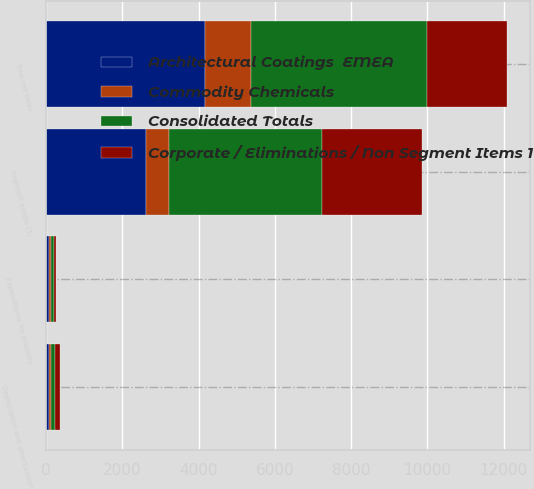Convert chart. <chart><loc_0><loc_0><loc_500><loc_500><stacked_bar_chart><ecel><fcel>Total net sales<fcel>Depreciation and amortization<fcel>Segment assets (5)<fcel>Expenditures for property<nl><fcel>Consolidated Totals<fcel>4626<fcel>115<fcel>4017<fcel>79<nl><fcel>Architectural Coatings  EMEA<fcel>4158<fcel>90<fcel>2614<fcel>73<nl><fcel>Corporate / Eliminations / Non Segment Items 1<fcel>2104<fcel>113<fcel>2626<fcel>48<nl><fcel>Commodity Chemicals<fcel>1207<fcel>36<fcel>610<fcel>54<nl></chart> 